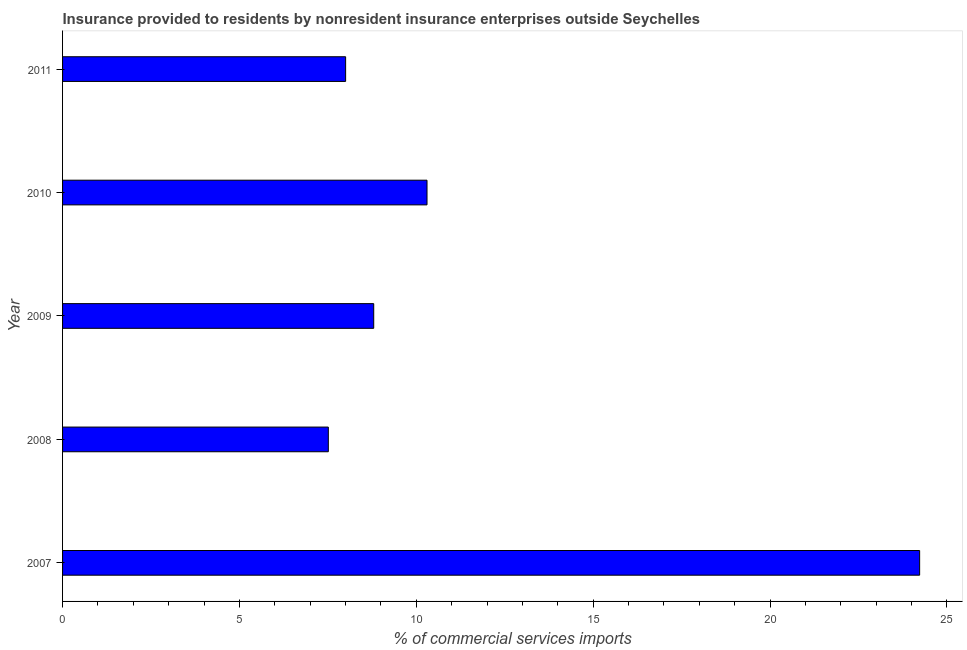Does the graph contain any zero values?
Make the answer very short. No. What is the title of the graph?
Provide a short and direct response. Insurance provided to residents by nonresident insurance enterprises outside Seychelles. What is the label or title of the X-axis?
Ensure brevity in your answer.  % of commercial services imports. What is the label or title of the Y-axis?
Your response must be concise. Year. What is the insurance provided by non-residents in 2010?
Give a very brief answer. 10.3. Across all years, what is the maximum insurance provided by non-residents?
Provide a short and direct response. 24.23. Across all years, what is the minimum insurance provided by non-residents?
Your response must be concise. 7.51. In which year was the insurance provided by non-residents maximum?
Offer a terse response. 2007. What is the sum of the insurance provided by non-residents?
Offer a terse response. 58.84. What is the difference between the insurance provided by non-residents in 2009 and 2010?
Offer a very short reply. -1.51. What is the average insurance provided by non-residents per year?
Your answer should be very brief. 11.77. What is the median insurance provided by non-residents?
Ensure brevity in your answer.  8.8. In how many years, is the insurance provided by non-residents greater than 19 %?
Your response must be concise. 1. What is the ratio of the insurance provided by non-residents in 2007 to that in 2010?
Keep it short and to the point. 2.35. What is the difference between the highest and the second highest insurance provided by non-residents?
Provide a short and direct response. 13.93. What is the difference between the highest and the lowest insurance provided by non-residents?
Make the answer very short. 16.71. How many bars are there?
Your answer should be compact. 5. Are all the bars in the graph horizontal?
Ensure brevity in your answer.  Yes. What is the difference between two consecutive major ticks on the X-axis?
Make the answer very short. 5. Are the values on the major ticks of X-axis written in scientific E-notation?
Provide a short and direct response. No. What is the % of commercial services imports in 2007?
Offer a very short reply. 24.23. What is the % of commercial services imports of 2008?
Your response must be concise. 7.51. What is the % of commercial services imports of 2009?
Provide a succinct answer. 8.8. What is the % of commercial services imports in 2010?
Ensure brevity in your answer.  10.3. What is the % of commercial services imports in 2011?
Provide a succinct answer. 8. What is the difference between the % of commercial services imports in 2007 and 2008?
Offer a very short reply. 16.71. What is the difference between the % of commercial services imports in 2007 and 2009?
Provide a short and direct response. 15.43. What is the difference between the % of commercial services imports in 2007 and 2010?
Provide a short and direct response. 13.93. What is the difference between the % of commercial services imports in 2007 and 2011?
Give a very brief answer. 16.23. What is the difference between the % of commercial services imports in 2008 and 2009?
Your response must be concise. -1.28. What is the difference between the % of commercial services imports in 2008 and 2010?
Your answer should be very brief. -2.79. What is the difference between the % of commercial services imports in 2008 and 2011?
Keep it short and to the point. -0.49. What is the difference between the % of commercial services imports in 2009 and 2010?
Offer a very short reply. -1.51. What is the difference between the % of commercial services imports in 2009 and 2011?
Provide a short and direct response. 0.79. What is the difference between the % of commercial services imports in 2010 and 2011?
Offer a very short reply. 2.3. What is the ratio of the % of commercial services imports in 2007 to that in 2008?
Provide a short and direct response. 3.23. What is the ratio of the % of commercial services imports in 2007 to that in 2009?
Keep it short and to the point. 2.75. What is the ratio of the % of commercial services imports in 2007 to that in 2010?
Keep it short and to the point. 2.35. What is the ratio of the % of commercial services imports in 2007 to that in 2011?
Your answer should be compact. 3.03. What is the ratio of the % of commercial services imports in 2008 to that in 2009?
Provide a succinct answer. 0.85. What is the ratio of the % of commercial services imports in 2008 to that in 2010?
Make the answer very short. 0.73. What is the ratio of the % of commercial services imports in 2008 to that in 2011?
Your answer should be compact. 0.94. What is the ratio of the % of commercial services imports in 2009 to that in 2010?
Give a very brief answer. 0.85. What is the ratio of the % of commercial services imports in 2009 to that in 2011?
Your answer should be compact. 1.1. What is the ratio of the % of commercial services imports in 2010 to that in 2011?
Provide a short and direct response. 1.29. 